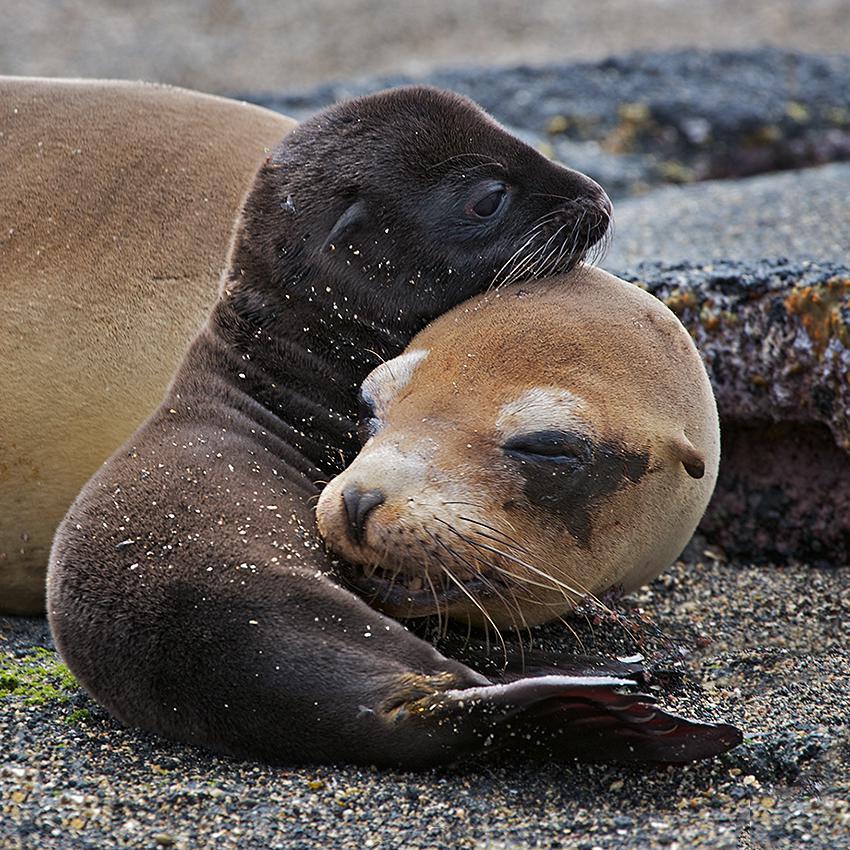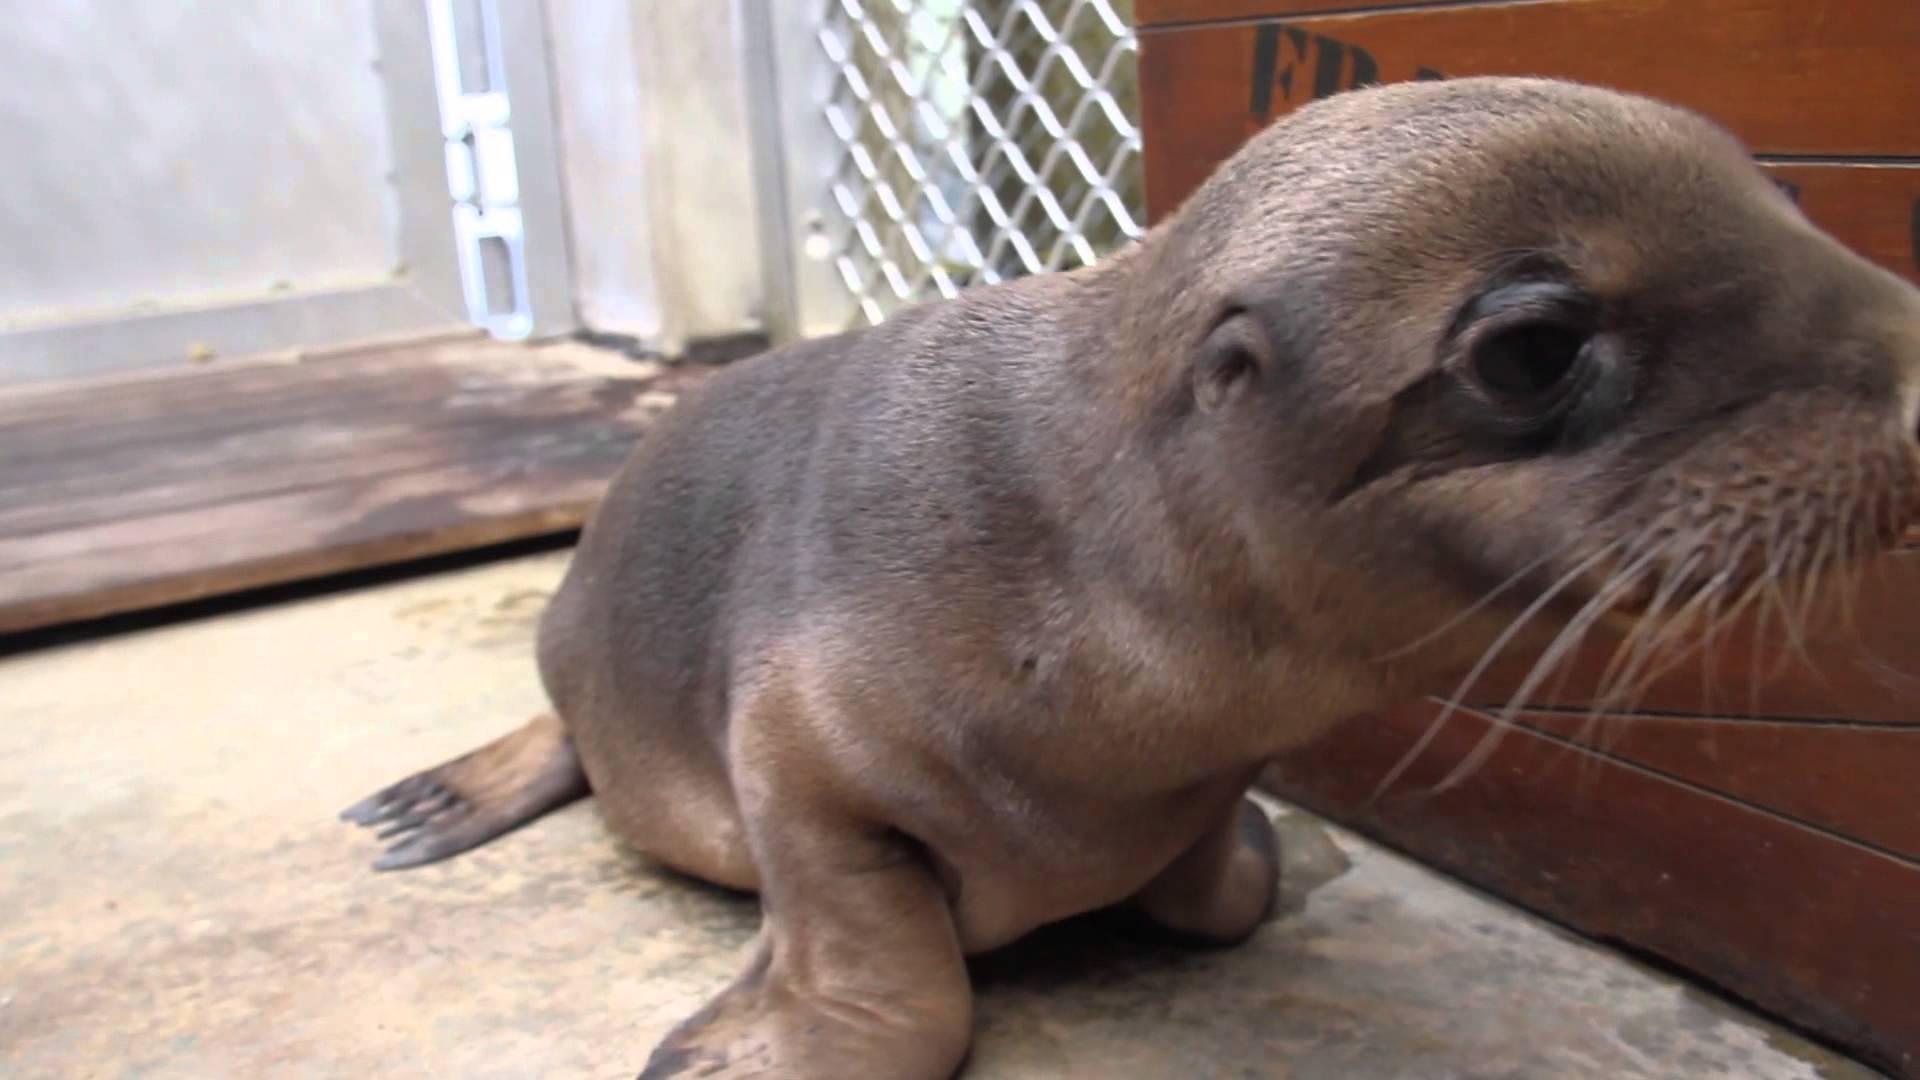The first image is the image on the left, the second image is the image on the right. Analyze the images presented: Is the assertion "An adult seal extends its neck to nuzzle a baby seal with its nose in at least one image." valid? Answer yes or no. No. The first image is the image on the left, the second image is the image on the right. Examine the images to the left and right. Is the description "Both images show a adult seal with a baby seal." accurate? Answer yes or no. No. 